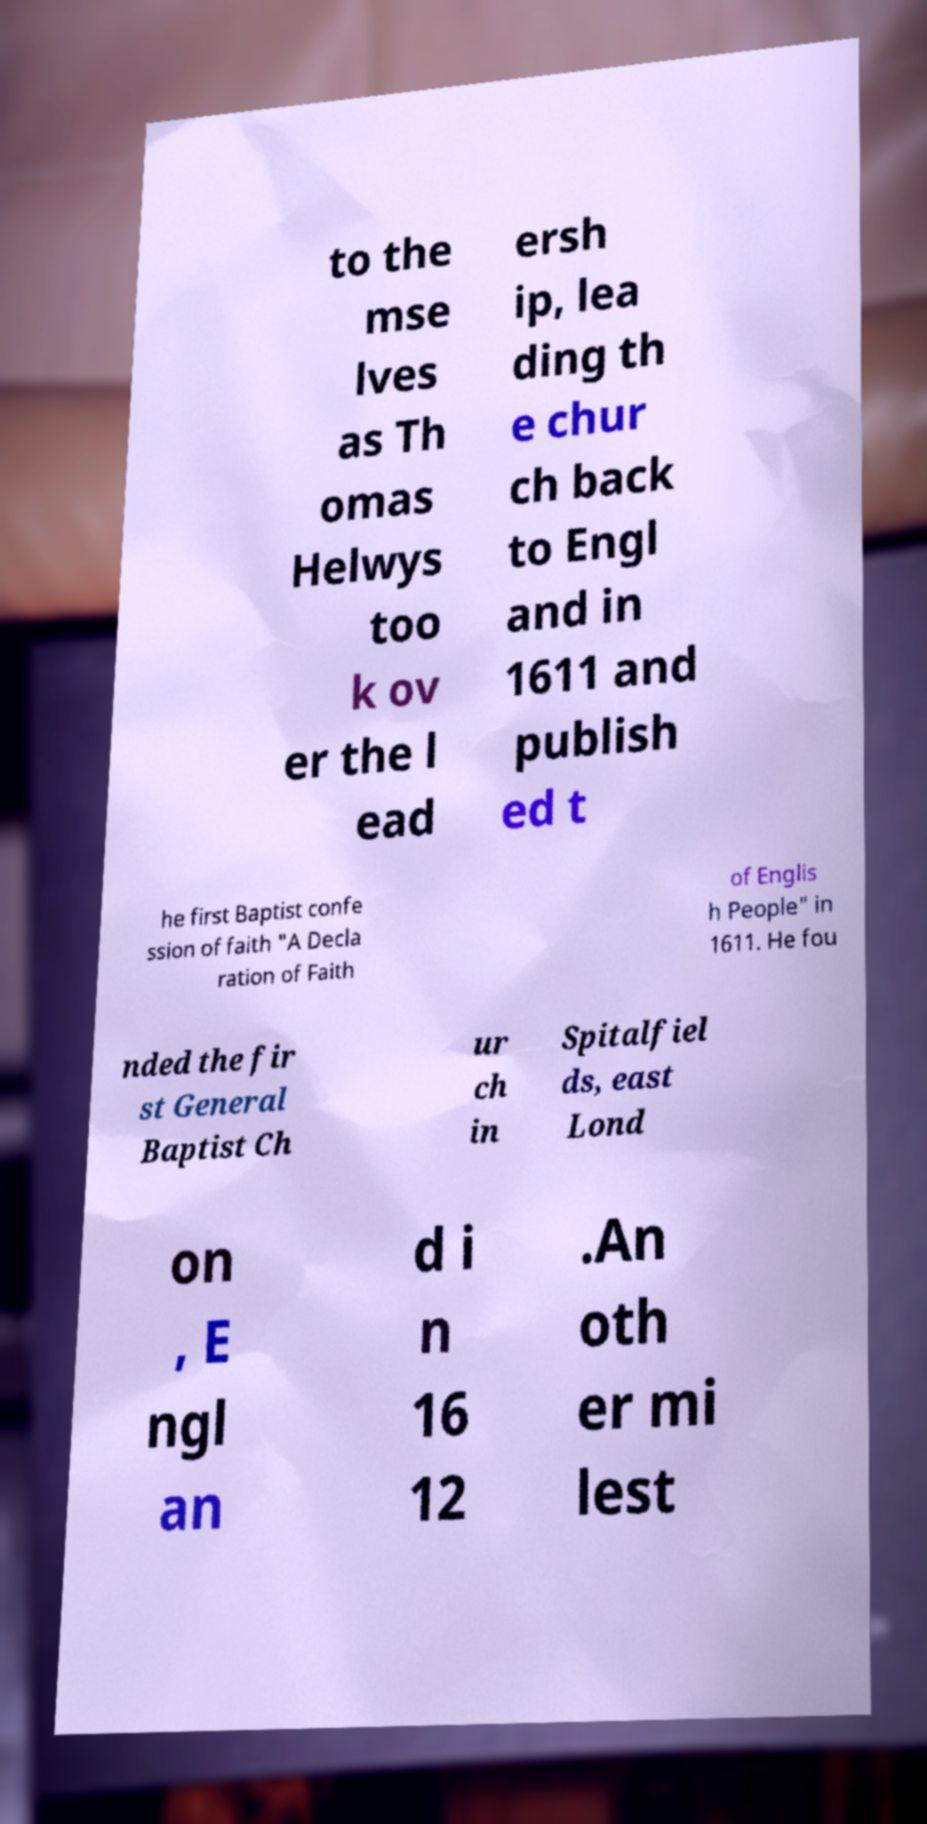Could you assist in decoding the text presented in this image and type it out clearly? to the mse lves as Th omas Helwys too k ov er the l ead ersh ip, lea ding th e chur ch back to Engl and in 1611 and publish ed t he first Baptist confe ssion of faith "A Decla ration of Faith of Englis h People" in 1611. He fou nded the fir st General Baptist Ch ur ch in Spitalfiel ds, east Lond on , E ngl an d i n 16 12 .An oth er mi lest 